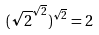<formula> <loc_0><loc_0><loc_500><loc_500>( \sqrt { 2 } ^ { \sqrt { 2 } } ) ^ { \sqrt { 2 } } = 2</formula> 